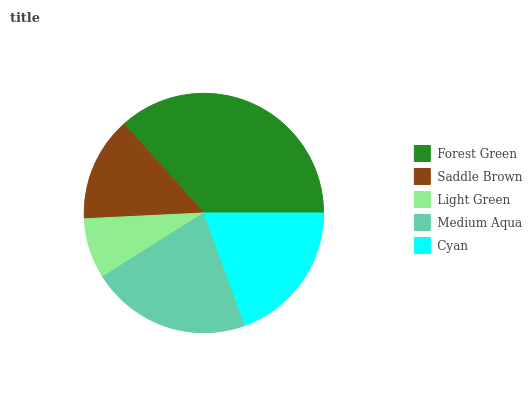Is Light Green the minimum?
Answer yes or no. Yes. Is Forest Green the maximum?
Answer yes or no. Yes. Is Saddle Brown the minimum?
Answer yes or no. No. Is Saddle Brown the maximum?
Answer yes or no. No. Is Forest Green greater than Saddle Brown?
Answer yes or no. Yes. Is Saddle Brown less than Forest Green?
Answer yes or no. Yes. Is Saddle Brown greater than Forest Green?
Answer yes or no. No. Is Forest Green less than Saddle Brown?
Answer yes or no. No. Is Cyan the high median?
Answer yes or no. Yes. Is Cyan the low median?
Answer yes or no. Yes. Is Medium Aqua the high median?
Answer yes or no. No. Is Light Green the low median?
Answer yes or no. No. 